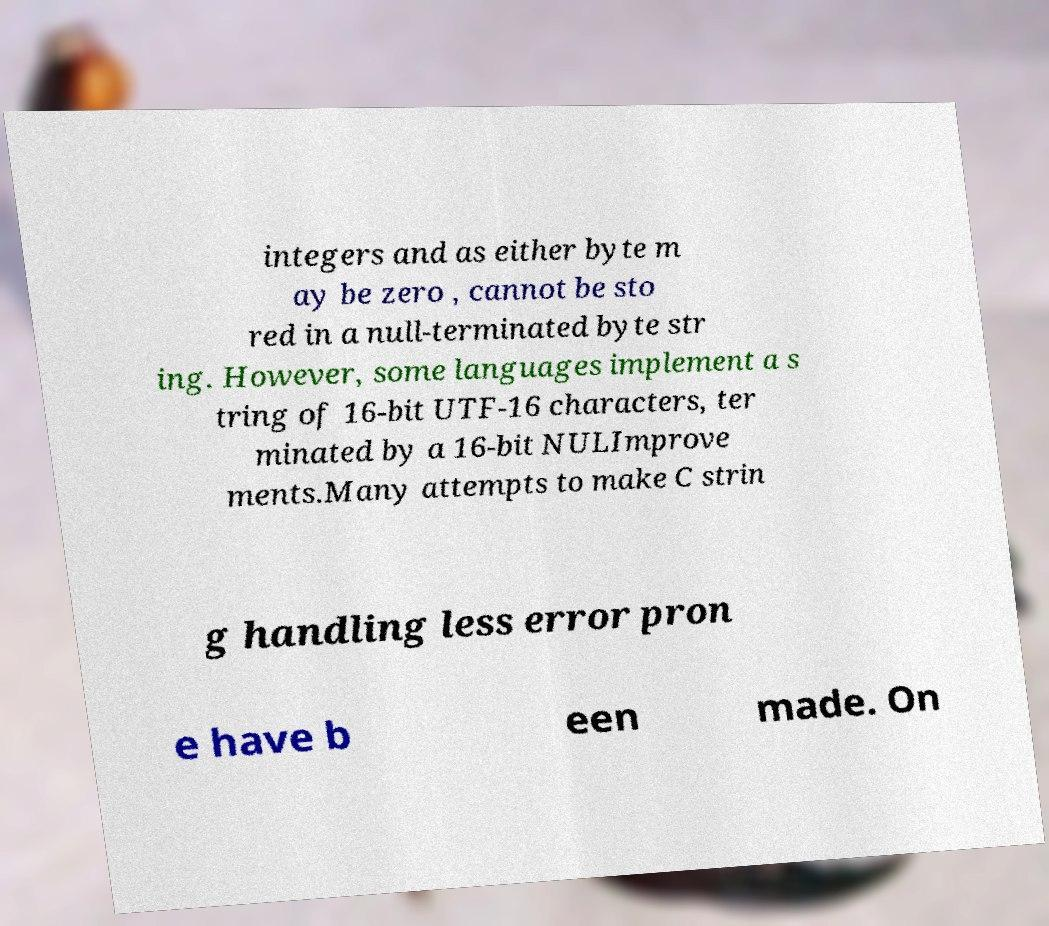What messages or text are displayed in this image? I need them in a readable, typed format. integers and as either byte m ay be zero , cannot be sto red in a null-terminated byte str ing. However, some languages implement a s tring of 16-bit UTF-16 characters, ter minated by a 16-bit NULImprove ments.Many attempts to make C strin g handling less error pron e have b een made. On 